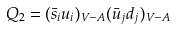Convert formula to latex. <formula><loc_0><loc_0><loc_500><loc_500>Q _ { 2 } = ( \bar { s } _ { i } u _ { i } ) _ { V - A } ( \bar { u } _ { j } d _ { j } ) _ { V - A }</formula> 